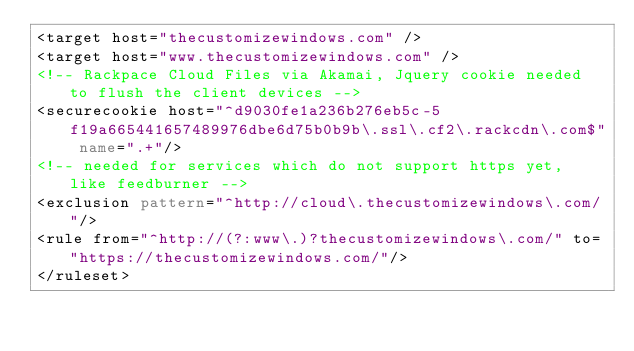<code> <loc_0><loc_0><loc_500><loc_500><_XML_><target host="thecustomizewindows.com" />
<target host="www.thecustomizewindows.com" />
<!-- Rackpace Cloud Files via Akamai, Jquery cookie needed to flush the client devices -->
<securecookie host="^d9030fe1a236b276eb5c-5f19a665441657489976dbe6d75b0b9b\.ssl\.cf2\.rackcdn\.com$" name=".+"/> 
<!-- needed for services which do not support https yet, like feedburner -->
<exclusion pattern="^http://cloud\.thecustomizewindows\.com/"/>
<rule from="^http://(?:www\.)?thecustomizewindows\.com/" to="https://thecustomizewindows.com/"/>
</ruleset>
</code> 